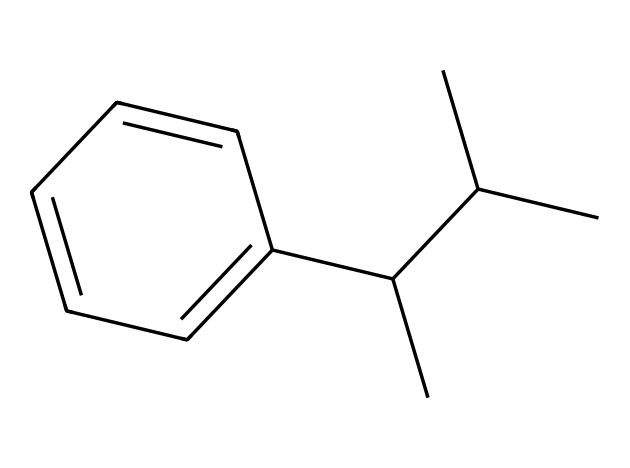What is the primary element in this chemical structure? The chemical consists primarily of carbon atoms, which are the backbone of its structure, confirmed by the multiple carbon-carbon bonds and how it forms a long chain typical of plastics.
Answer: carbon How many hydrogen atoms are present in the structure? By visual inspection of the SMILES representation, each carbon that is not involved in a double bond or bonded to another carbon must be bonded to hydrogen atoms to satisfy carbon's tetravalency. Counting carefully, the total hydrogen atoms amount to 10.
Answer: 10 What type of functional groups are present in this molecule? In the given structure, there are no specific functional groups like -OH or -COOH; the molecule is primarily composed of only aromatic hydrocarbon groups—indicating it does not contain typical polar functional groups.
Answer: none Is this compound aromatic? The chemical structure contains a benzene ring, which is clearly denoted by alternating double bonds, indicating the presence of resonance and characteristic aromaticity.
Answer: yes What is the expected use of this chemical? Given its properties as a thermoplastic polymer with durability and insulation capabilities, this compound is commonly used for applications in disposable food containers and thermal insulation.
Answer: food containers and insulation What is the degree of saturation in this compound? The structure is fully saturated with single bonds between carbon atoms in the alkyl groups and has a delocalized electron system in the aromatic ring, signifying that it contains no double or triple bonds beyond those in the ring.
Answer: fully saturated How does the structure influence its physical properties? The long hydrocarbon chain and aromatic ring confer flexibility and durability, key characteristics of polystyrene, allowing it to provide mechanical strength and thermal resistance, crucial for its use in packaging and insulation.
Answer: flexibility and durability 